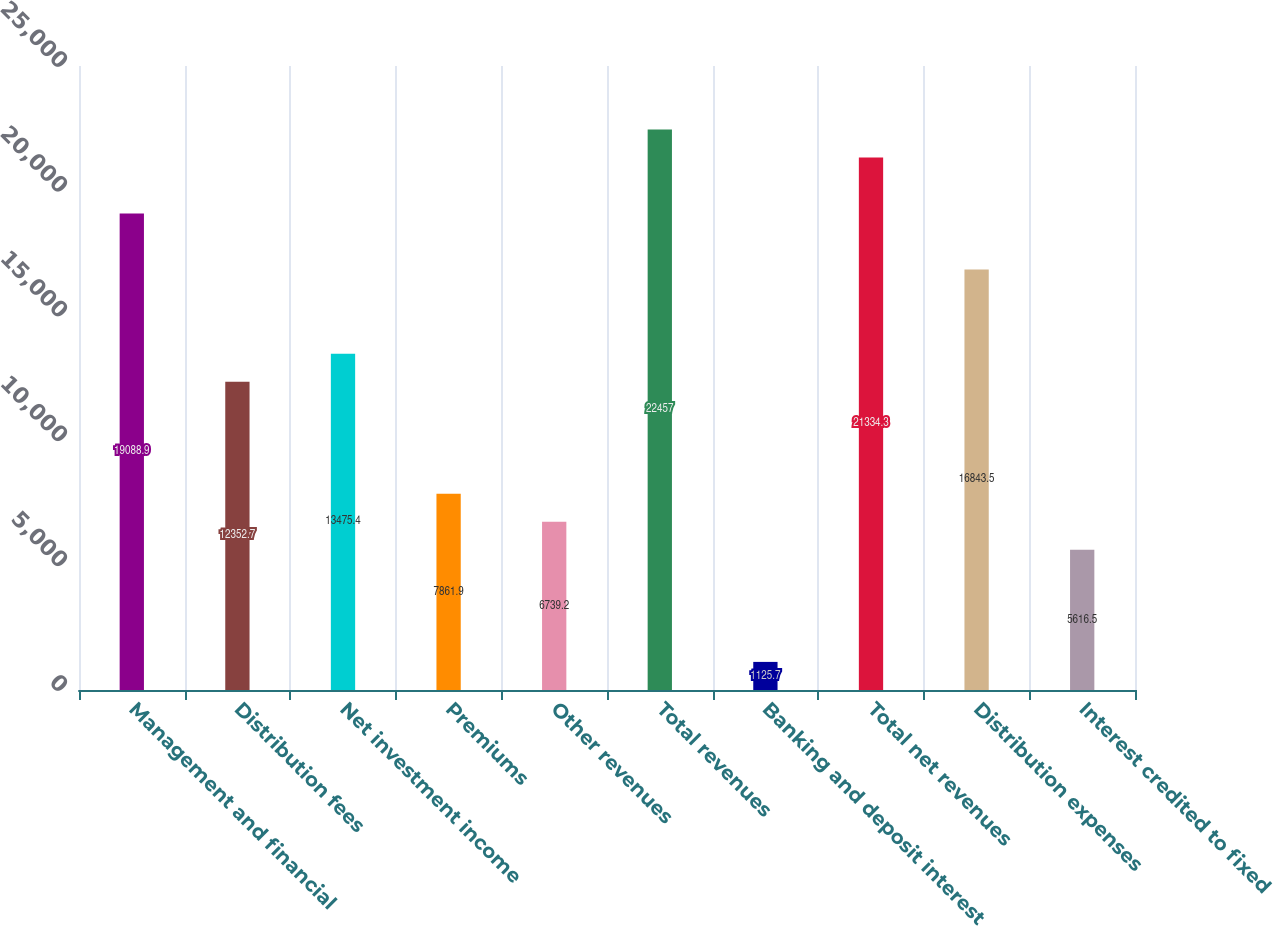<chart> <loc_0><loc_0><loc_500><loc_500><bar_chart><fcel>Management and financial<fcel>Distribution fees<fcel>Net investment income<fcel>Premiums<fcel>Other revenues<fcel>Total revenues<fcel>Banking and deposit interest<fcel>Total net revenues<fcel>Distribution expenses<fcel>Interest credited to fixed<nl><fcel>19088.9<fcel>12352.7<fcel>13475.4<fcel>7861.9<fcel>6739.2<fcel>22457<fcel>1125.7<fcel>21334.3<fcel>16843.5<fcel>5616.5<nl></chart> 